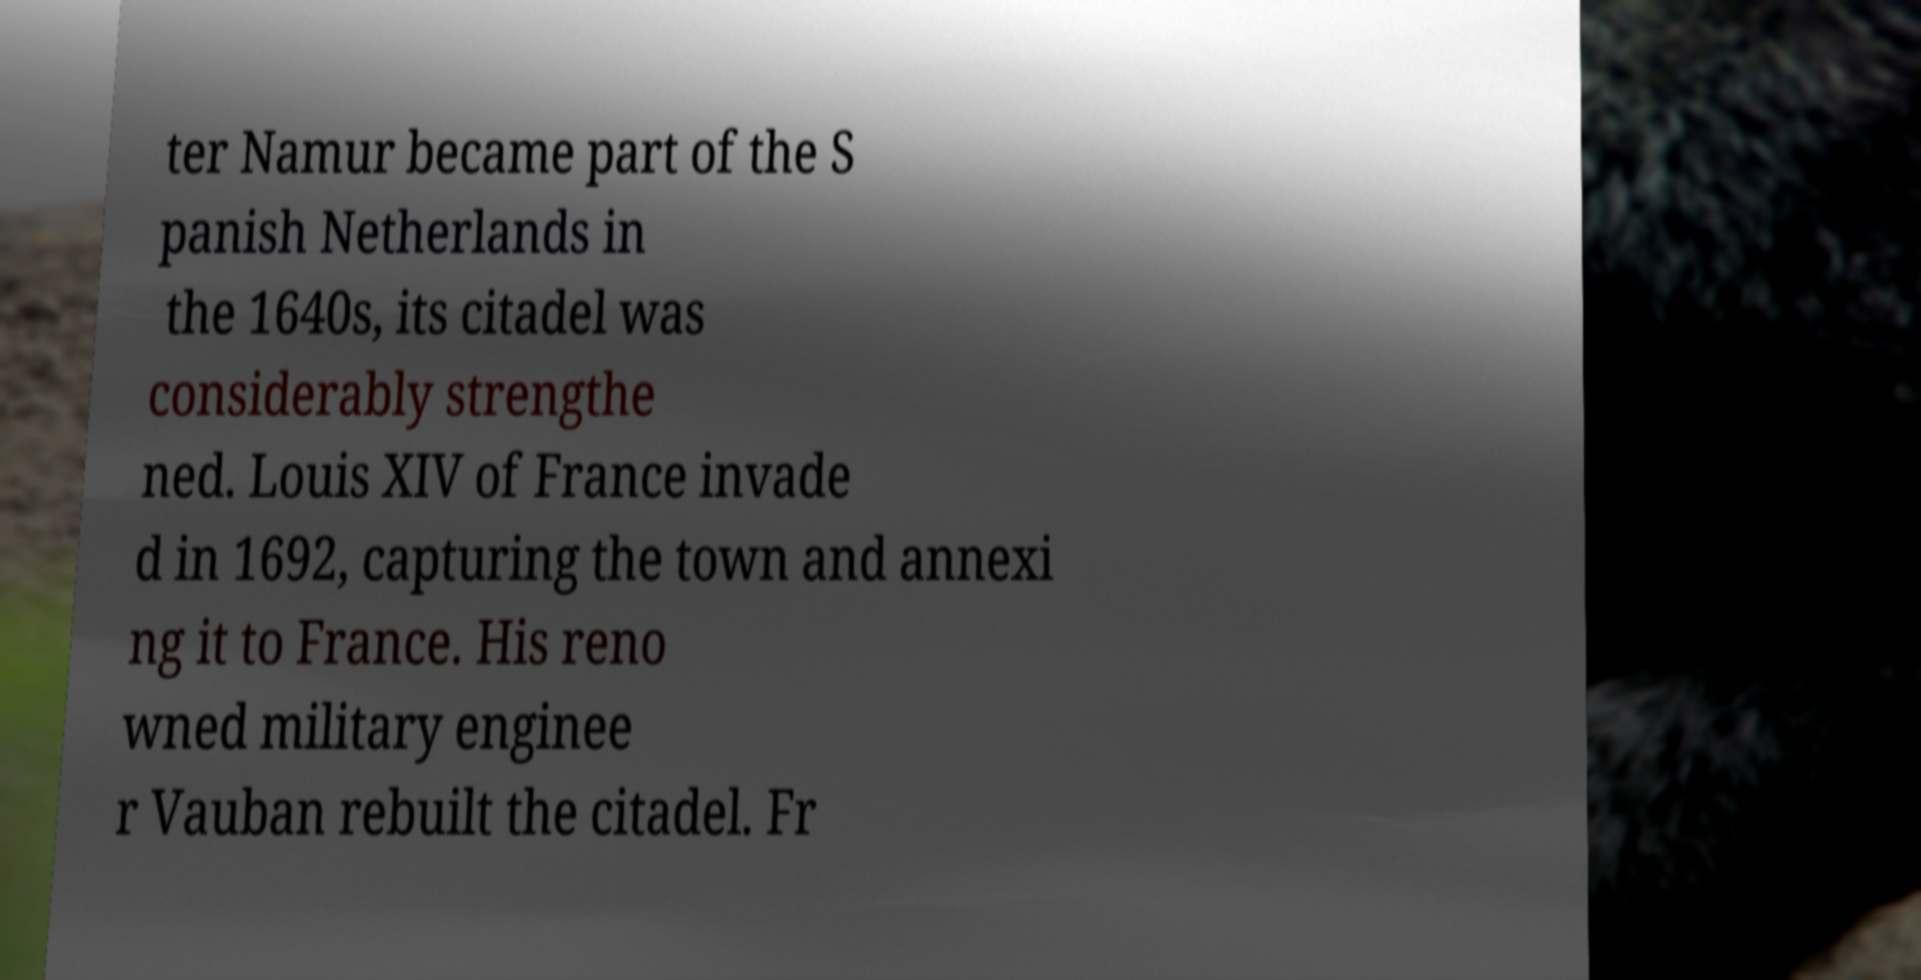Could you extract and type out the text from this image? ter Namur became part of the S panish Netherlands in the 1640s, its citadel was considerably strengthe ned. Louis XIV of France invade d in 1692, capturing the town and annexi ng it to France. His reno wned military enginee r Vauban rebuilt the citadel. Fr 